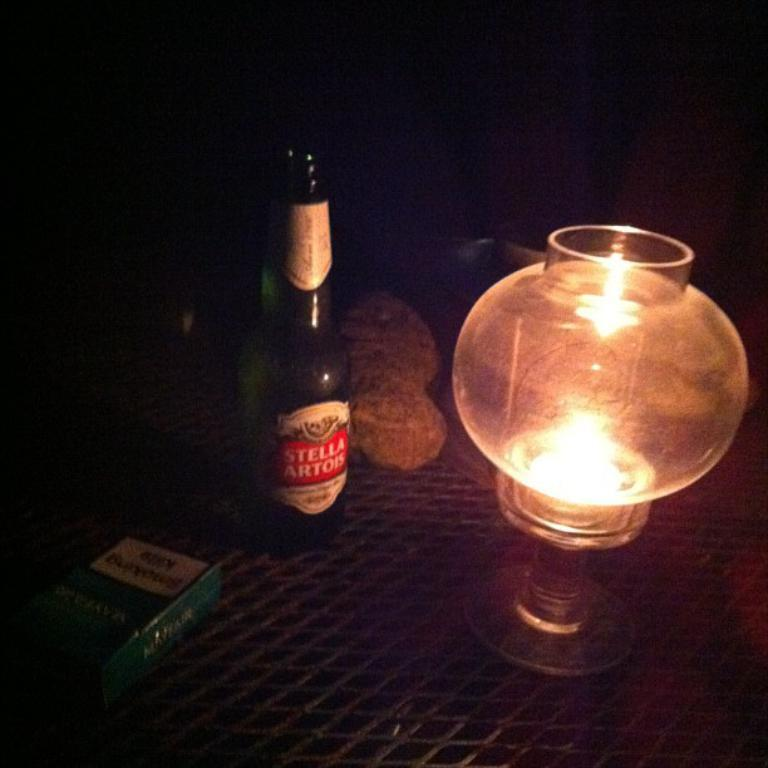<image>
Create a compact narrative representing the image presented. A bottle of Stella Artois sits next to a candle lit lantern on a wire table. 